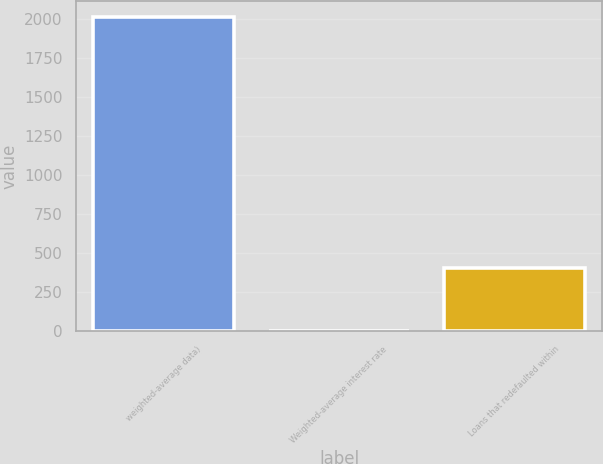<chart> <loc_0><loc_0><loc_500><loc_500><bar_chart><fcel>weighted-average data)<fcel>Weighted-average interest rate<fcel>Loans that redefaulted within<nl><fcel>2012<fcel>5.19<fcel>406.55<nl></chart> 